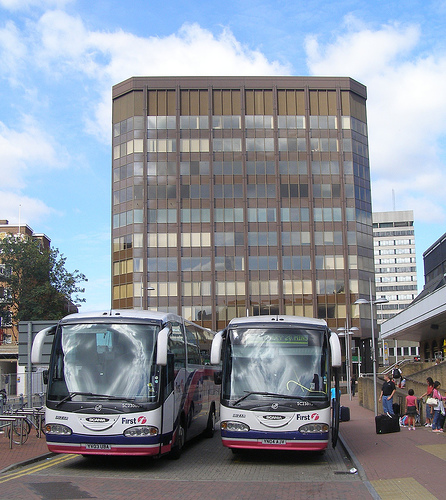Is the person on the left side? No, the people visible in the image are located on the right side, primarily grouped around and interacting near the buses. 